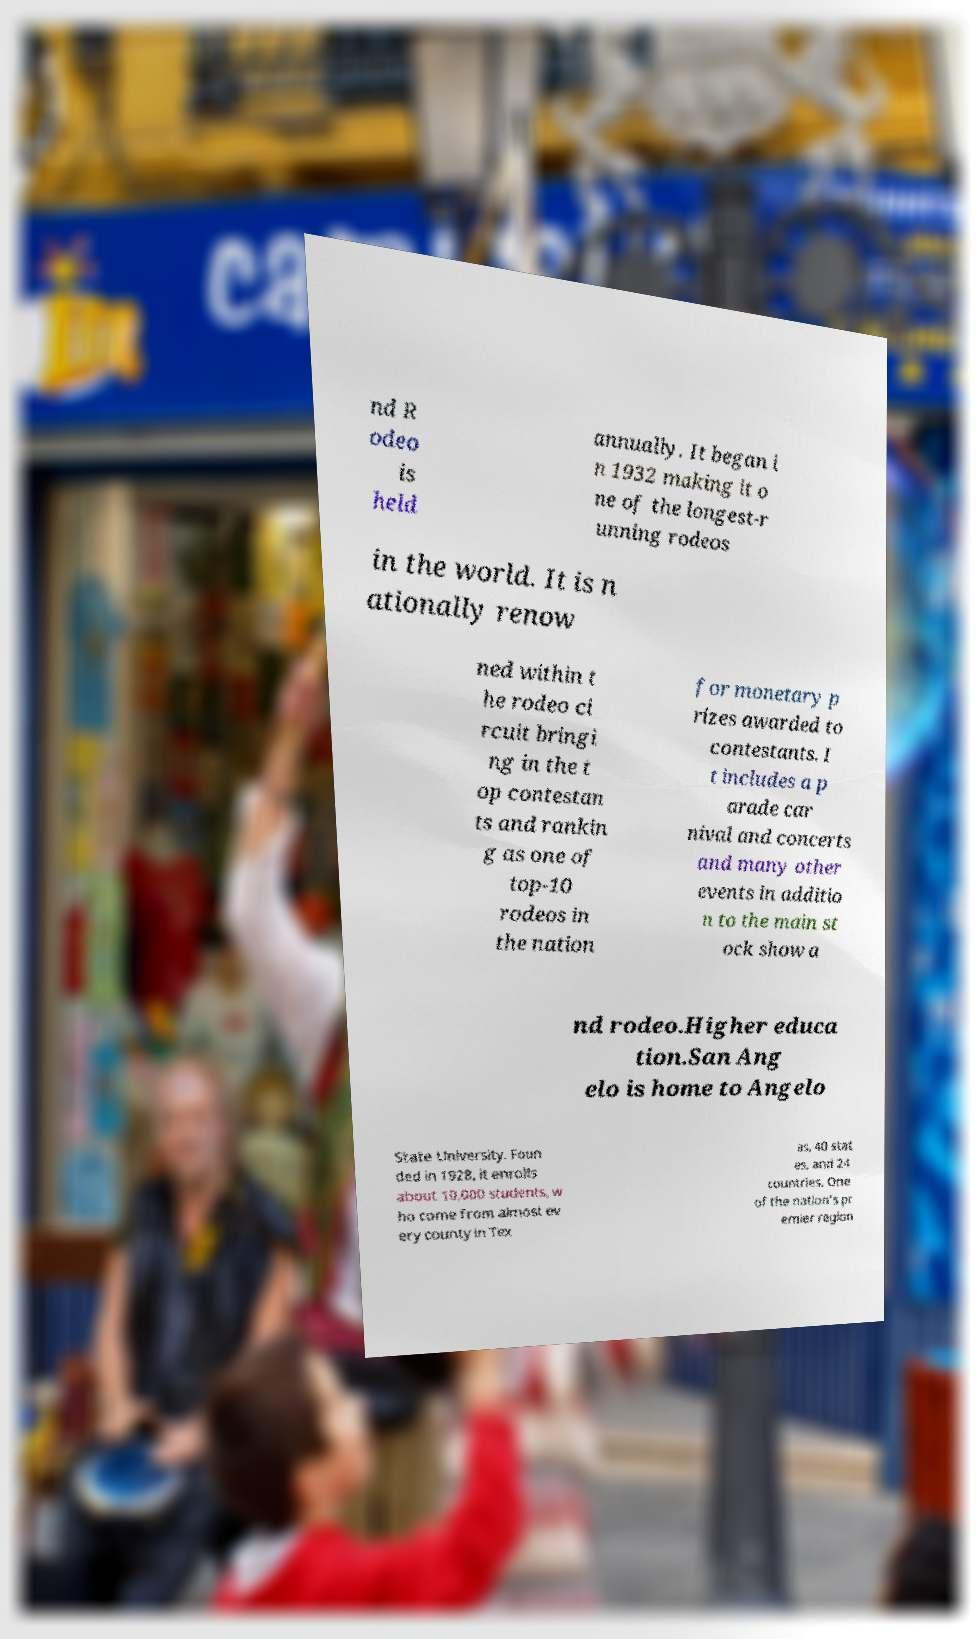Can you accurately transcribe the text from the provided image for me? nd R odeo is held annually. It began i n 1932 making it o ne of the longest-r unning rodeos in the world. It is n ationally renow ned within t he rodeo ci rcuit bringi ng in the t op contestan ts and rankin g as one of top-10 rodeos in the nation for monetary p rizes awarded to contestants. I t includes a p arade car nival and concerts and many other events in additio n to the main st ock show a nd rodeo.Higher educa tion.San Ang elo is home to Angelo State University. Foun ded in 1928, it enrolls about 10,000 students, w ho come from almost ev ery county in Tex as, 40 stat es, and 24 countries. One of the nation's pr emier region 